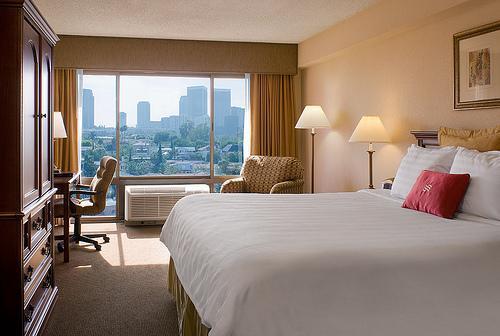How many lamp shades are visible?
Give a very brief answer. 3. 